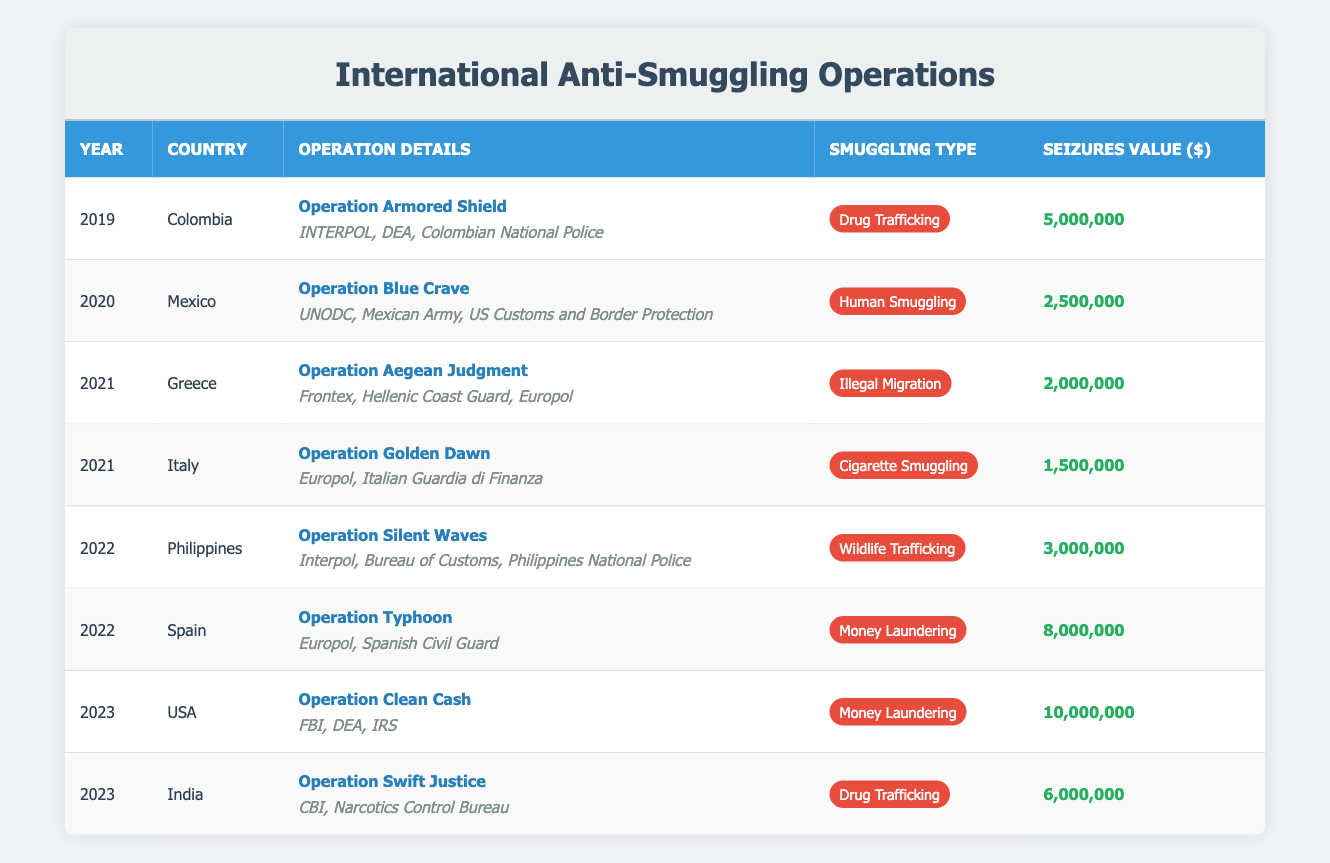What was the total value of seizures in 2022? The total value of seizures in 2022 consists of values from the operations in the Philippines (3,000,000) and Spain (8,000,000). Adding these gives 3,000,000 + 8,000,000 = 11,000,000.
Answer: 11,000,000 Which country had the highest seizure value from the operations listed? The USA had the highest seizure value in 2023 with Operation Clean Cash, totaling 10,000,000. Checking the seizure values for all countries confirms that this is the highest amount.
Answer: USA Did any operations in 2021 address human smuggling? The data shows operations for Greece and Italy in 2021, which dealt with Illegal Migration and Cigarette Smuggling, respectively. No operations targeted human smuggling in that year.
Answer: No How many unique countries participated in the operations between 2019 and 2023? The unique countries are Colombia, Mexico, Greece, Italy, Philippines, Spain, USA, and India. Counting these gives a total of 8 unique countries involved in the operations from 2019 to 2023.
Answer: 8 What is the total value of seizures from drug trafficking operations? The operations for drug trafficking were in Colombia (5,000,000), India (6,000,000), summing these values gives 5,000,000 + 6,000,000 = 11,000,000.
Answer: 11,000,000 Which year saw an operation focusing on wildlife trafficking? The operation focusing on wildlife trafficking occurred in the Philippines in 2022, specifically named Operation Silent Waves. This can be confirmed by examining the smuggling types listed per year.
Answer: 2022 Was Operation Aegean Judgment aimed at human smuggling? Operation Aegean Judgment targeted Illegal Migration in Greece for the year 2021, but that is not classified as human smuggling in the terms used here.
Answer: No What is the highest seizure value from any operation listed? The highest seizure value is from the USA in 2023 with Operation Clean Cash, reaching 10,000,000. This value can be validated by checking all seizure values.
Answer: 10,000,000 